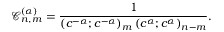Convert formula to latex. <formula><loc_0><loc_0><loc_500><loc_500>\mathcal { C } _ { n , m } ^ { ( \alpha ) } = \frac { 1 } { \left ( c ^ { - \alpha } ; c ^ { - \alpha } \right ) _ { m } \left ( c ^ { \alpha } ; c ^ { \alpha } \right ) _ { n - m } } .</formula> 